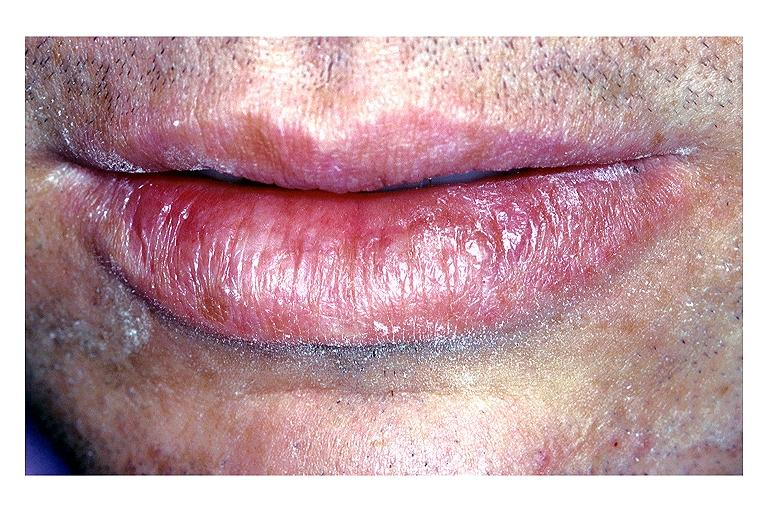s maxillary sinus present?
Answer the question using a single word or phrase. No 